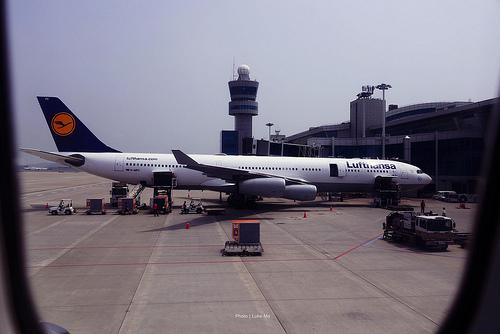Question: when are planes loaded?
Choices:
A. On the runway.
B. Before take off.
C. During passenger loading.
D. At the airport.
Answer with the letter. Answer: B Question: who drives the plane?
Choices:
A. Pilot.
B. Captian.
C. Co-pilot.
D. First officer.
Answer with the letter. Answer: A Question: what is in the background?
Choices:
A. Mountains.
B. Trees.
C. Buildings.
D. Control tower.
Answer with the letter. Answer: D Question: why is the plane there?
Choices:
A. Loading passengers.
B. Being repaired.
C. Unloading passengers.
D. Loading luggage.
Answer with the letter. Answer: D 